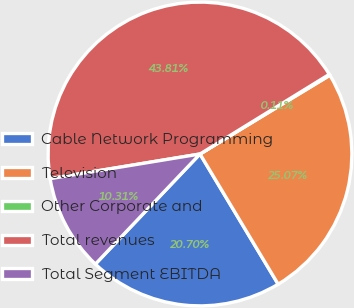<chart> <loc_0><loc_0><loc_500><loc_500><pie_chart><fcel>Cable Network Programming<fcel>Television<fcel>Other Corporate and<fcel>Total revenues<fcel>Total Segment EBITDA<nl><fcel>20.7%<fcel>25.07%<fcel>0.11%<fcel>43.81%<fcel>10.31%<nl></chart> 